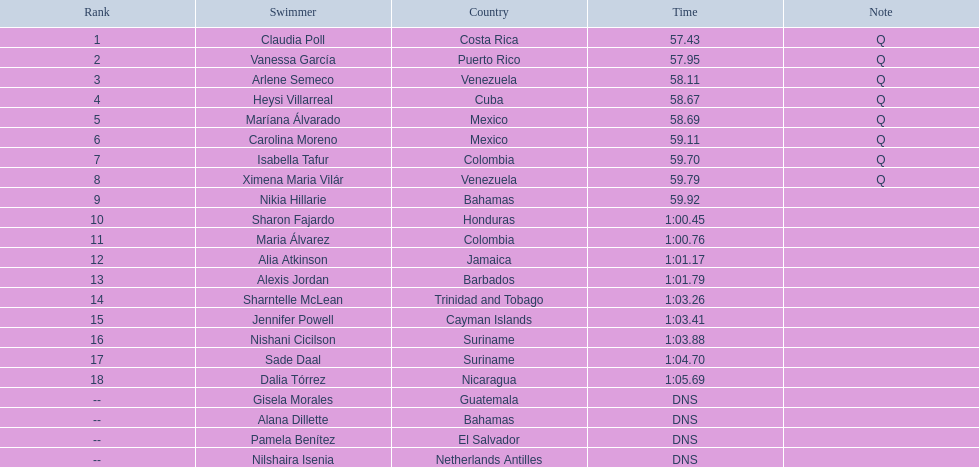Who were all of the swimmers in the women's 100 metre freestyle? Claudia Poll, Vanessa García, Arlene Semeco, Heysi Villarreal, Maríana Álvarado, Carolina Moreno, Isabella Tafur, Ximena Maria Vilár, Nikia Hillarie, Sharon Fajardo, Maria Álvarez, Alia Atkinson, Alexis Jordan, Sharntelle McLean, Jennifer Powell, Nishani Cicilson, Sade Daal, Dalia Tórrez, Gisela Morales, Alana Dillette, Pamela Benítez, Nilshaira Isenia. Where was each swimmer from? Costa Rica, Puerto Rico, Venezuela, Cuba, Mexico, Mexico, Colombia, Venezuela, Bahamas, Honduras, Colombia, Jamaica, Barbados, Trinidad and Tobago, Cayman Islands, Suriname, Suriname, Nicaragua, Guatemala, Bahamas, El Salvador, Netherlands Antilles. What were their ranks? 1, 2, 3, 4, 5, 6, 7, 8, 9, 10, 11, 12, 13, 14, 15, 16, 17, 18, --, --, --, --. Who was in the top eight? Claudia Poll, Vanessa García, Arlene Semeco, Heysi Villarreal, Maríana Álvarado, Carolina Moreno, Isabella Tafur, Ximena Maria Vilár. Of those swimmers, which one was from cuba? Heysi Villarreal. 